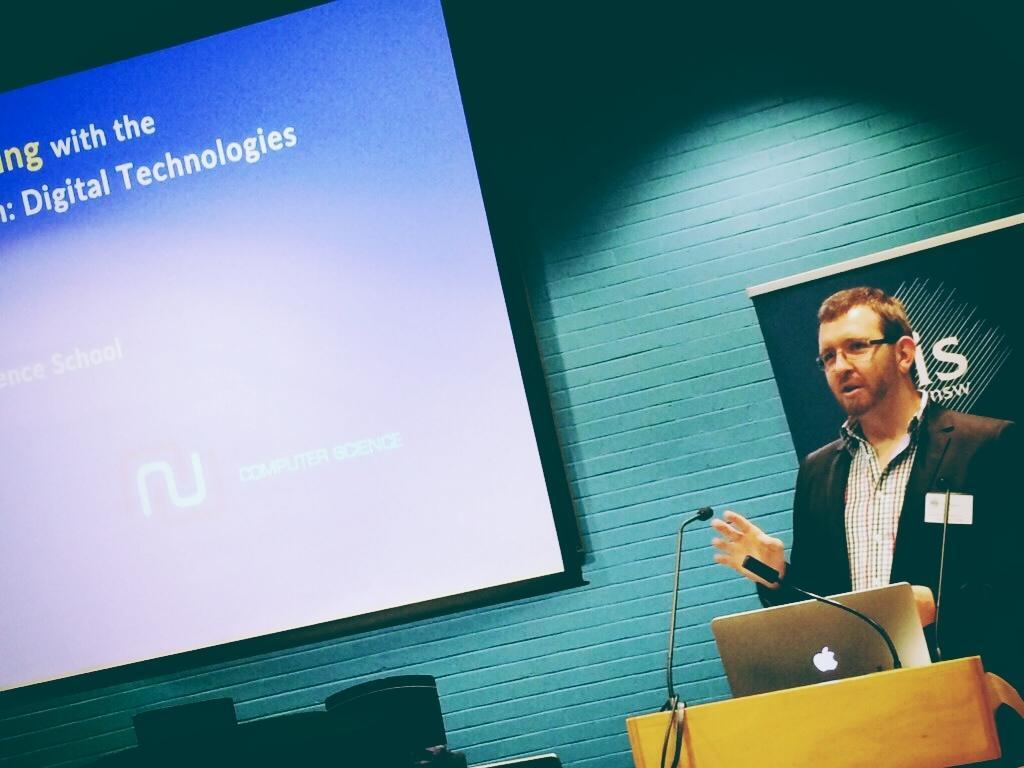In one or two sentences, can you explain what this image depicts? In this image I can see a person. There is a laptop on the podium. I can see the projector screen. In the background there is a wall. 